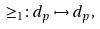Convert formula to latex. <formula><loc_0><loc_0><loc_500><loc_500>\geq _ { 1 } \colon d _ { p } \mapsto d _ { p } ,</formula> 